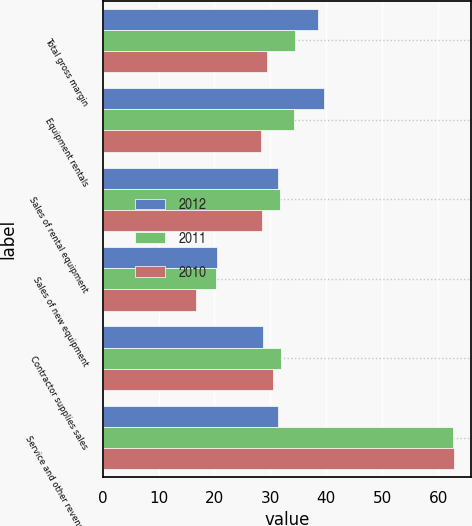Convert chart to OTSL. <chart><loc_0><loc_0><loc_500><loc_500><stacked_bar_chart><ecel><fcel>Total gross margin<fcel>Equipment rentals<fcel>Sales of rental equipment<fcel>Sales of new equipment<fcel>Contractor supplies sales<fcel>Service and other revenues<nl><fcel>2012<fcel>38.5<fcel>39.5<fcel>31.3<fcel>20.4<fcel>28.7<fcel>31.3<nl><fcel>2011<fcel>34.4<fcel>34.2<fcel>31.7<fcel>20.2<fcel>31.8<fcel>62.7<nl><fcel>2010<fcel>29.4<fcel>28.4<fcel>28.5<fcel>16.7<fcel>30.5<fcel>62.8<nl></chart> 